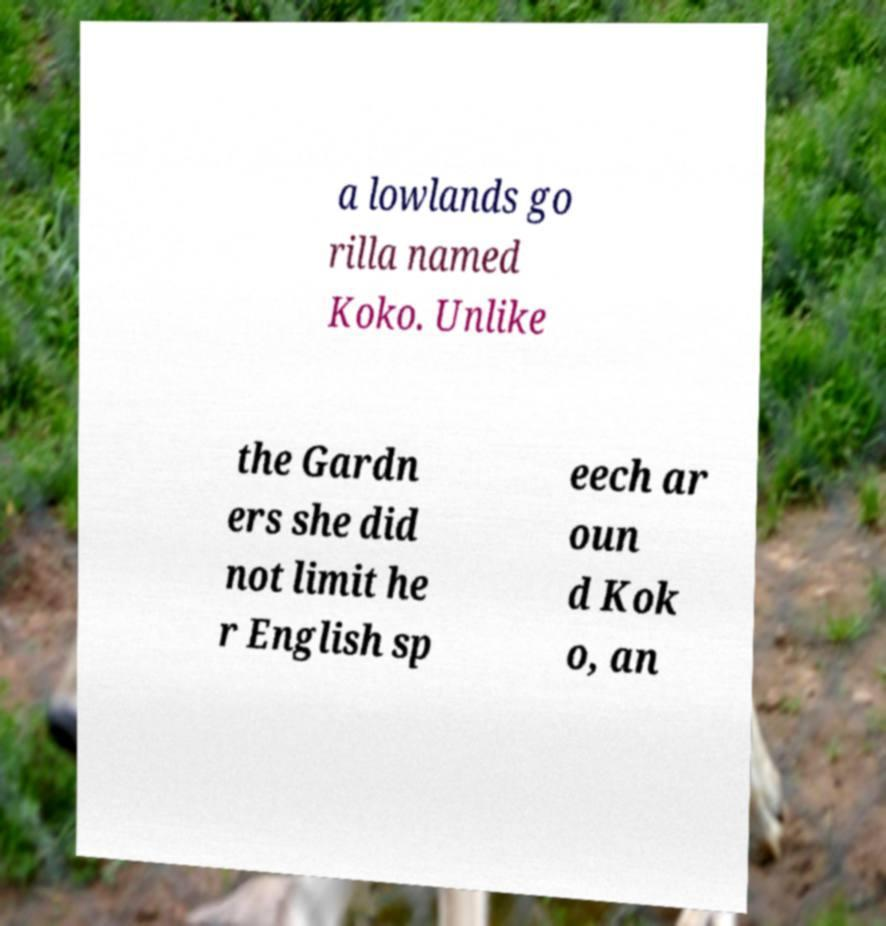What messages or text are displayed in this image? I need them in a readable, typed format. a lowlands go rilla named Koko. Unlike the Gardn ers she did not limit he r English sp eech ar oun d Kok o, an 